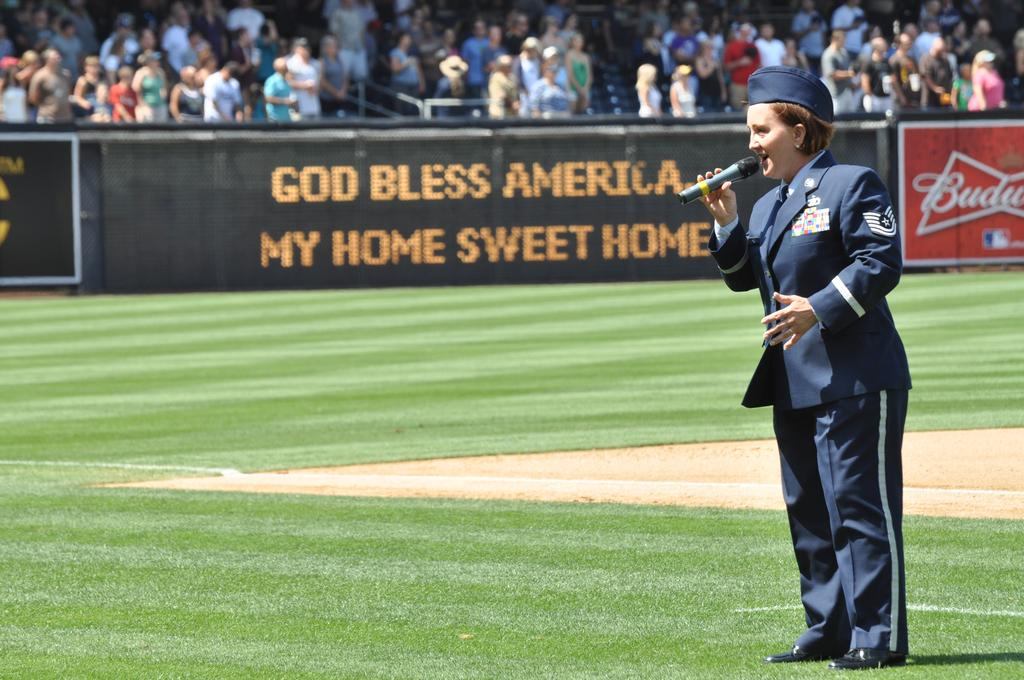<image>
Render a clear and concise summary of the photo. A woman in uniform sings into a microphone at a sports game in front of a sign that says God bless Americs my home sweet home 